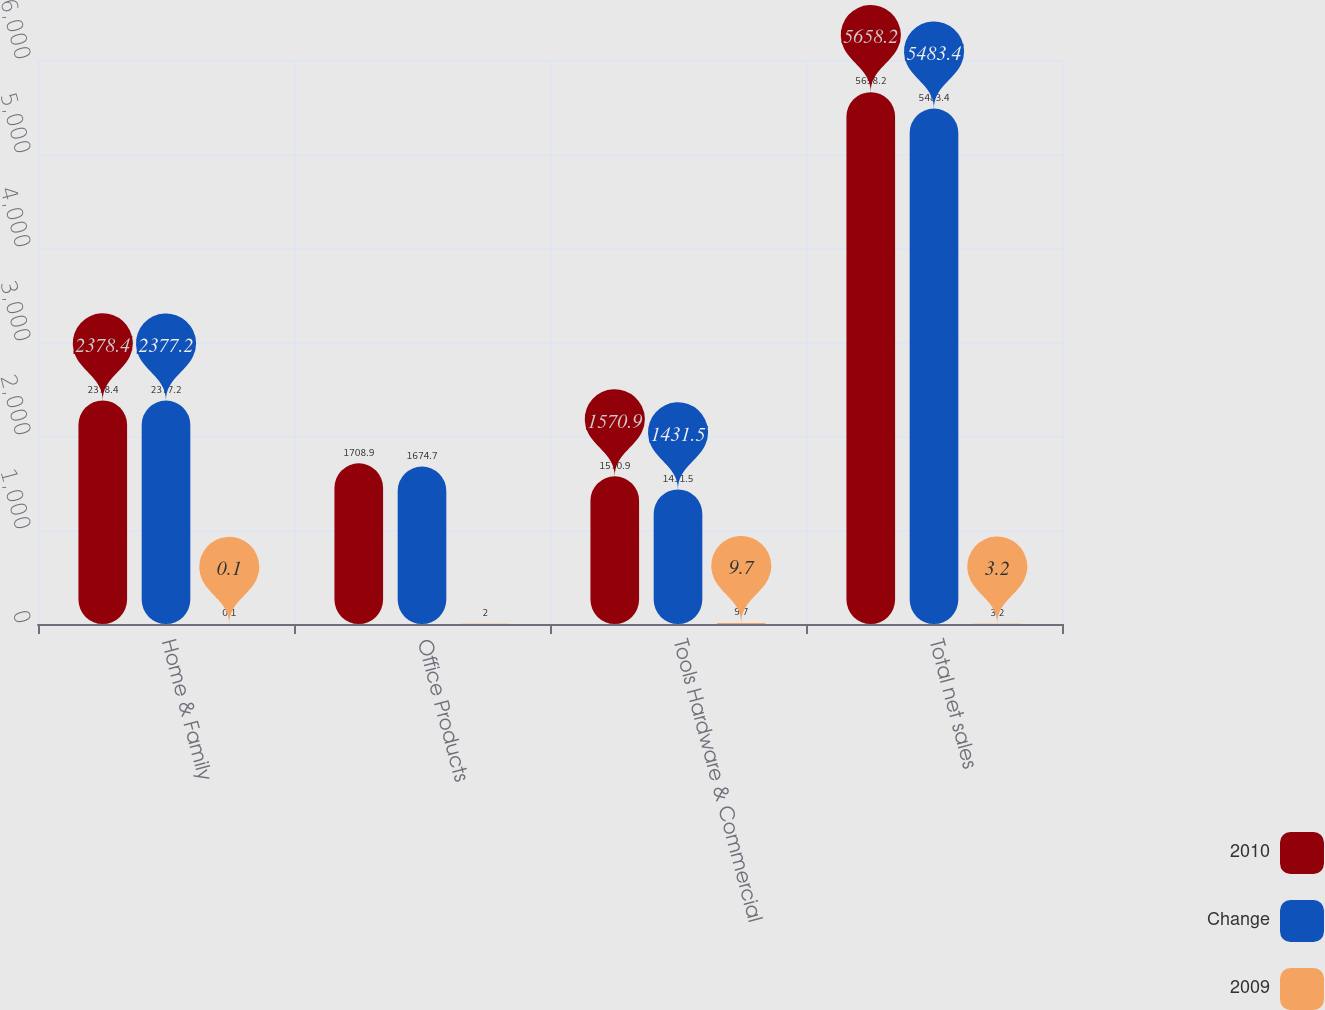Convert chart to OTSL. <chart><loc_0><loc_0><loc_500><loc_500><stacked_bar_chart><ecel><fcel>Home & Family<fcel>Office Products<fcel>Tools Hardware & Commercial<fcel>Total net sales<nl><fcel>2010<fcel>2378.4<fcel>1708.9<fcel>1570.9<fcel>5658.2<nl><fcel>Change<fcel>2377.2<fcel>1674.7<fcel>1431.5<fcel>5483.4<nl><fcel>2009<fcel>0.1<fcel>2<fcel>9.7<fcel>3.2<nl></chart> 